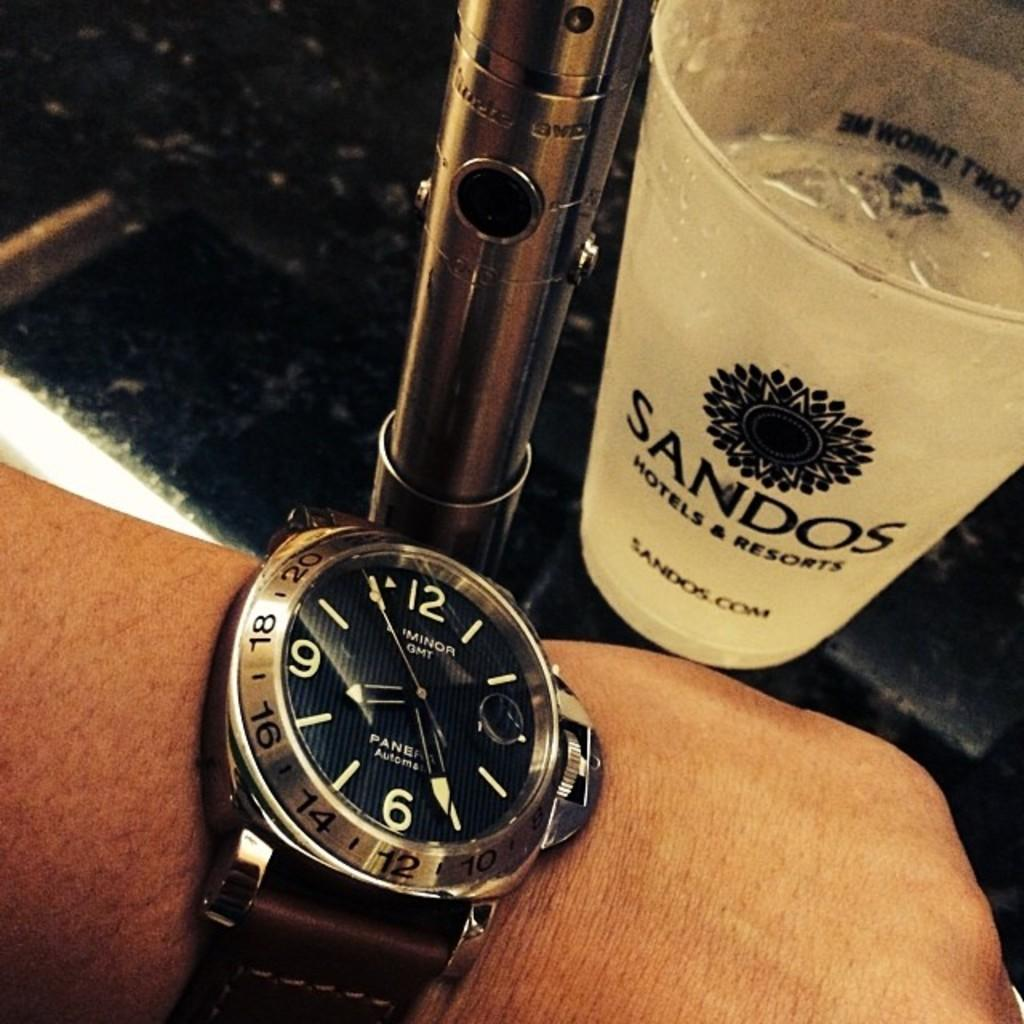<image>
Create a compact narrative representing the image presented. A watch is displayed next to a cup which says Sandos Hotels & Resorts. 